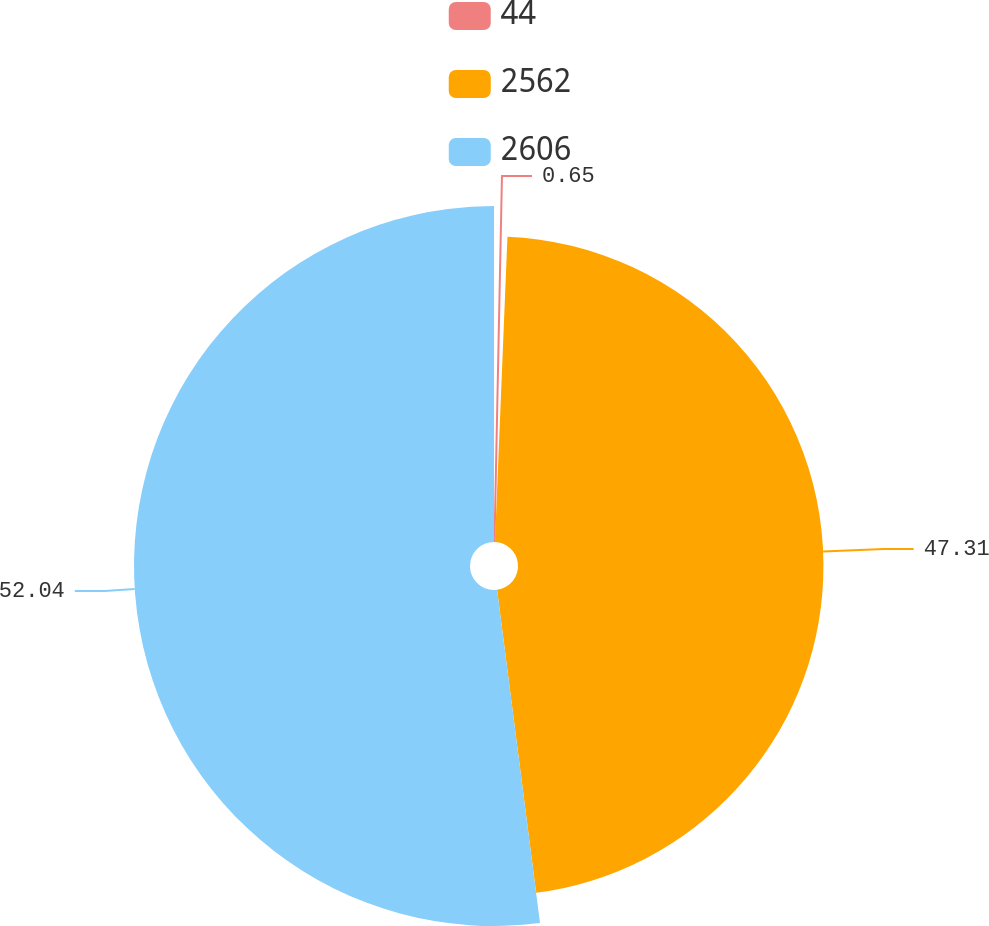Convert chart to OTSL. <chart><loc_0><loc_0><loc_500><loc_500><pie_chart><fcel>44<fcel>2562<fcel>2606<nl><fcel>0.65%<fcel>47.31%<fcel>52.04%<nl></chart> 